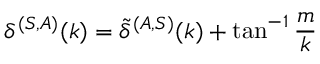Convert formula to latex. <formula><loc_0><loc_0><loc_500><loc_500>\delta ^ { ( S , A ) } ( k ) = \tilde { \delta } ^ { ( A , S ) } ( k ) + \tan ^ { - 1 } \frac { m } { k }</formula> 